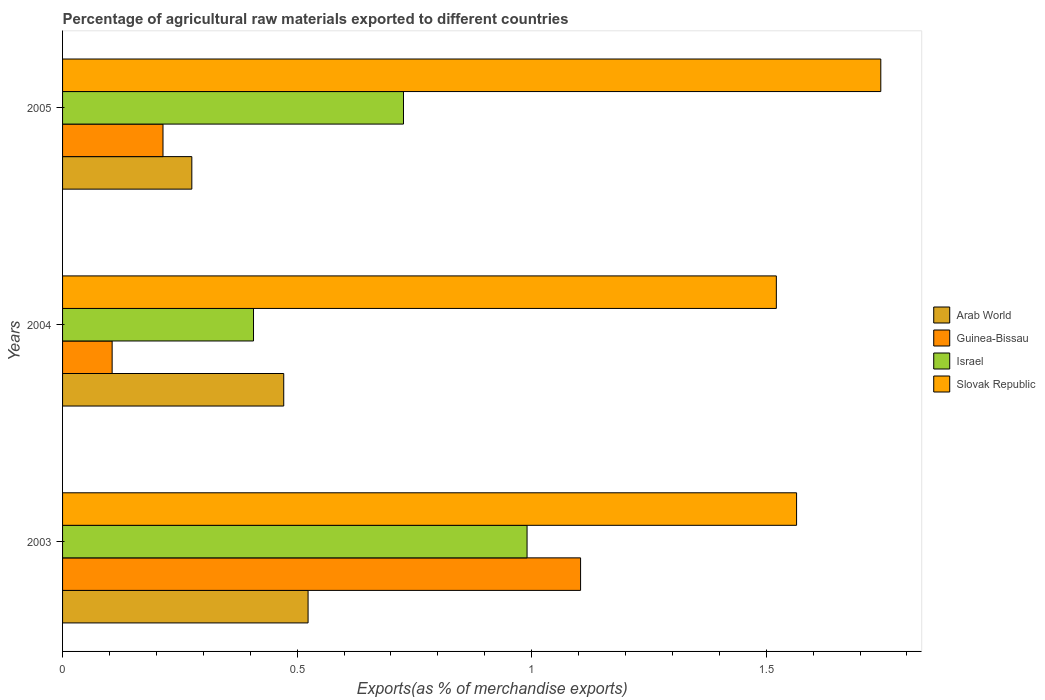How many different coloured bars are there?
Ensure brevity in your answer.  4. How many bars are there on the 1st tick from the top?
Keep it short and to the point. 4. In how many cases, is the number of bars for a given year not equal to the number of legend labels?
Your answer should be compact. 0. What is the percentage of exports to different countries in Guinea-Bissau in 2005?
Keep it short and to the point. 0.21. Across all years, what is the maximum percentage of exports to different countries in Israel?
Keep it short and to the point. 0.99. Across all years, what is the minimum percentage of exports to different countries in Guinea-Bissau?
Provide a succinct answer. 0.11. In which year was the percentage of exports to different countries in Israel minimum?
Your answer should be very brief. 2004. What is the total percentage of exports to different countries in Arab World in the graph?
Your answer should be very brief. 1.27. What is the difference between the percentage of exports to different countries in Slovak Republic in 2003 and that in 2005?
Ensure brevity in your answer.  -0.18. What is the difference between the percentage of exports to different countries in Arab World in 2004 and the percentage of exports to different countries in Guinea-Bissau in 2003?
Your answer should be very brief. -0.63. What is the average percentage of exports to different countries in Arab World per year?
Make the answer very short. 0.42. In the year 2005, what is the difference between the percentage of exports to different countries in Arab World and percentage of exports to different countries in Guinea-Bissau?
Make the answer very short. 0.06. In how many years, is the percentage of exports to different countries in Guinea-Bissau greater than 1.6 %?
Your answer should be compact. 0. What is the ratio of the percentage of exports to different countries in Arab World in 2004 to that in 2005?
Your answer should be very brief. 1.71. Is the percentage of exports to different countries in Slovak Republic in 2004 less than that in 2005?
Provide a short and direct response. Yes. Is the difference between the percentage of exports to different countries in Arab World in 2004 and 2005 greater than the difference between the percentage of exports to different countries in Guinea-Bissau in 2004 and 2005?
Offer a very short reply. Yes. What is the difference between the highest and the second highest percentage of exports to different countries in Israel?
Make the answer very short. 0.26. What is the difference between the highest and the lowest percentage of exports to different countries in Guinea-Bissau?
Ensure brevity in your answer.  1. Is the sum of the percentage of exports to different countries in Slovak Republic in 2003 and 2004 greater than the maximum percentage of exports to different countries in Guinea-Bissau across all years?
Make the answer very short. Yes. What does the 1st bar from the top in 2004 represents?
Keep it short and to the point. Slovak Republic. Is it the case that in every year, the sum of the percentage of exports to different countries in Slovak Republic and percentage of exports to different countries in Israel is greater than the percentage of exports to different countries in Arab World?
Your response must be concise. Yes. Are the values on the major ticks of X-axis written in scientific E-notation?
Offer a very short reply. No. Does the graph contain any zero values?
Give a very brief answer. No. Does the graph contain grids?
Your response must be concise. No. How are the legend labels stacked?
Your answer should be compact. Vertical. What is the title of the graph?
Offer a terse response. Percentage of agricultural raw materials exported to different countries. Does "Montenegro" appear as one of the legend labels in the graph?
Give a very brief answer. No. What is the label or title of the X-axis?
Make the answer very short. Exports(as % of merchandise exports). What is the label or title of the Y-axis?
Provide a succinct answer. Years. What is the Exports(as % of merchandise exports) of Arab World in 2003?
Offer a very short reply. 0.52. What is the Exports(as % of merchandise exports) in Guinea-Bissau in 2003?
Your response must be concise. 1.1. What is the Exports(as % of merchandise exports) of Israel in 2003?
Your answer should be very brief. 0.99. What is the Exports(as % of merchandise exports) of Slovak Republic in 2003?
Your answer should be very brief. 1.56. What is the Exports(as % of merchandise exports) in Arab World in 2004?
Your response must be concise. 0.47. What is the Exports(as % of merchandise exports) in Guinea-Bissau in 2004?
Your response must be concise. 0.11. What is the Exports(as % of merchandise exports) in Israel in 2004?
Offer a terse response. 0.41. What is the Exports(as % of merchandise exports) of Slovak Republic in 2004?
Offer a terse response. 1.52. What is the Exports(as % of merchandise exports) of Arab World in 2005?
Your response must be concise. 0.28. What is the Exports(as % of merchandise exports) of Guinea-Bissau in 2005?
Give a very brief answer. 0.21. What is the Exports(as % of merchandise exports) in Israel in 2005?
Offer a terse response. 0.73. What is the Exports(as % of merchandise exports) in Slovak Republic in 2005?
Your answer should be compact. 1.74. Across all years, what is the maximum Exports(as % of merchandise exports) in Arab World?
Provide a short and direct response. 0.52. Across all years, what is the maximum Exports(as % of merchandise exports) in Guinea-Bissau?
Ensure brevity in your answer.  1.1. Across all years, what is the maximum Exports(as % of merchandise exports) in Israel?
Offer a terse response. 0.99. Across all years, what is the maximum Exports(as % of merchandise exports) in Slovak Republic?
Offer a very short reply. 1.74. Across all years, what is the minimum Exports(as % of merchandise exports) of Arab World?
Ensure brevity in your answer.  0.28. Across all years, what is the minimum Exports(as % of merchandise exports) in Guinea-Bissau?
Provide a succinct answer. 0.11. Across all years, what is the minimum Exports(as % of merchandise exports) of Israel?
Offer a very short reply. 0.41. Across all years, what is the minimum Exports(as % of merchandise exports) in Slovak Republic?
Keep it short and to the point. 1.52. What is the total Exports(as % of merchandise exports) in Arab World in the graph?
Provide a succinct answer. 1.27. What is the total Exports(as % of merchandise exports) of Guinea-Bissau in the graph?
Offer a very short reply. 1.42. What is the total Exports(as % of merchandise exports) of Israel in the graph?
Your answer should be compact. 2.12. What is the total Exports(as % of merchandise exports) in Slovak Republic in the graph?
Keep it short and to the point. 4.83. What is the difference between the Exports(as % of merchandise exports) in Arab World in 2003 and that in 2004?
Make the answer very short. 0.05. What is the difference between the Exports(as % of merchandise exports) in Israel in 2003 and that in 2004?
Keep it short and to the point. 0.58. What is the difference between the Exports(as % of merchandise exports) in Slovak Republic in 2003 and that in 2004?
Your answer should be very brief. 0.04. What is the difference between the Exports(as % of merchandise exports) of Arab World in 2003 and that in 2005?
Your answer should be very brief. 0.25. What is the difference between the Exports(as % of merchandise exports) in Guinea-Bissau in 2003 and that in 2005?
Your response must be concise. 0.89. What is the difference between the Exports(as % of merchandise exports) of Israel in 2003 and that in 2005?
Offer a very short reply. 0.26. What is the difference between the Exports(as % of merchandise exports) of Slovak Republic in 2003 and that in 2005?
Make the answer very short. -0.18. What is the difference between the Exports(as % of merchandise exports) of Arab World in 2004 and that in 2005?
Provide a succinct answer. 0.2. What is the difference between the Exports(as % of merchandise exports) of Guinea-Bissau in 2004 and that in 2005?
Provide a succinct answer. -0.11. What is the difference between the Exports(as % of merchandise exports) in Israel in 2004 and that in 2005?
Make the answer very short. -0.32. What is the difference between the Exports(as % of merchandise exports) in Slovak Republic in 2004 and that in 2005?
Make the answer very short. -0.22. What is the difference between the Exports(as % of merchandise exports) of Arab World in 2003 and the Exports(as % of merchandise exports) of Guinea-Bissau in 2004?
Make the answer very short. 0.42. What is the difference between the Exports(as % of merchandise exports) in Arab World in 2003 and the Exports(as % of merchandise exports) in Israel in 2004?
Ensure brevity in your answer.  0.12. What is the difference between the Exports(as % of merchandise exports) in Arab World in 2003 and the Exports(as % of merchandise exports) in Slovak Republic in 2004?
Your response must be concise. -1. What is the difference between the Exports(as % of merchandise exports) of Guinea-Bissau in 2003 and the Exports(as % of merchandise exports) of Israel in 2004?
Provide a short and direct response. 0.7. What is the difference between the Exports(as % of merchandise exports) in Guinea-Bissau in 2003 and the Exports(as % of merchandise exports) in Slovak Republic in 2004?
Make the answer very short. -0.42. What is the difference between the Exports(as % of merchandise exports) of Israel in 2003 and the Exports(as % of merchandise exports) of Slovak Republic in 2004?
Keep it short and to the point. -0.53. What is the difference between the Exports(as % of merchandise exports) in Arab World in 2003 and the Exports(as % of merchandise exports) in Guinea-Bissau in 2005?
Your response must be concise. 0.31. What is the difference between the Exports(as % of merchandise exports) of Arab World in 2003 and the Exports(as % of merchandise exports) of Israel in 2005?
Offer a very short reply. -0.2. What is the difference between the Exports(as % of merchandise exports) of Arab World in 2003 and the Exports(as % of merchandise exports) of Slovak Republic in 2005?
Ensure brevity in your answer.  -1.22. What is the difference between the Exports(as % of merchandise exports) in Guinea-Bissau in 2003 and the Exports(as % of merchandise exports) in Israel in 2005?
Keep it short and to the point. 0.38. What is the difference between the Exports(as % of merchandise exports) of Guinea-Bissau in 2003 and the Exports(as % of merchandise exports) of Slovak Republic in 2005?
Offer a terse response. -0.64. What is the difference between the Exports(as % of merchandise exports) of Israel in 2003 and the Exports(as % of merchandise exports) of Slovak Republic in 2005?
Make the answer very short. -0.75. What is the difference between the Exports(as % of merchandise exports) in Arab World in 2004 and the Exports(as % of merchandise exports) in Guinea-Bissau in 2005?
Give a very brief answer. 0.26. What is the difference between the Exports(as % of merchandise exports) of Arab World in 2004 and the Exports(as % of merchandise exports) of Israel in 2005?
Ensure brevity in your answer.  -0.26. What is the difference between the Exports(as % of merchandise exports) in Arab World in 2004 and the Exports(as % of merchandise exports) in Slovak Republic in 2005?
Your response must be concise. -1.27. What is the difference between the Exports(as % of merchandise exports) in Guinea-Bissau in 2004 and the Exports(as % of merchandise exports) in Israel in 2005?
Provide a short and direct response. -0.62. What is the difference between the Exports(as % of merchandise exports) in Guinea-Bissau in 2004 and the Exports(as % of merchandise exports) in Slovak Republic in 2005?
Your response must be concise. -1.64. What is the difference between the Exports(as % of merchandise exports) of Israel in 2004 and the Exports(as % of merchandise exports) of Slovak Republic in 2005?
Provide a short and direct response. -1.34. What is the average Exports(as % of merchandise exports) in Arab World per year?
Your response must be concise. 0.42. What is the average Exports(as % of merchandise exports) of Guinea-Bissau per year?
Keep it short and to the point. 0.47. What is the average Exports(as % of merchandise exports) of Israel per year?
Your answer should be very brief. 0.71. What is the average Exports(as % of merchandise exports) of Slovak Republic per year?
Offer a very short reply. 1.61. In the year 2003, what is the difference between the Exports(as % of merchandise exports) in Arab World and Exports(as % of merchandise exports) in Guinea-Bissau?
Ensure brevity in your answer.  -0.58. In the year 2003, what is the difference between the Exports(as % of merchandise exports) of Arab World and Exports(as % of merchandise exports) of Israel?
Ensure brevity in your answer.  -0.47. In the year 2003, what is the difference between the Exports(as % of merchandise exports) in Arab World and Exports(as % of merchandise exports) in Slovak Republic?
Provide a short and direct response. -1.04. In the year 2003, what is the difference between the Exports(as % of merchandise exports) in Guinea-Bissau and Exports(as % of merchandise exports) in Israel?
Your response must be concise. 0.11. In the year 2003, what is the difference between the Exports(as % of merchandise exports) of Guinea-Bissau and Exports(as % of merchandise exports) of Slovak Republic?
Make the answer very short. -0.46. In the year 2003, what is the difference between the Exports(as % of merchandise exports) in Israel and Exports(as % of merchandise exports) in Slovak Republic?
Keep it short and to the point. -0.57. In the year 2004, what is the difference between the Exports(as % of merchandise exports) in Arab World and Exports(as % of merchandise exports) in Guinea-Bissau?
Give a very brief answer. 0.37. In the year 2004, what is the difference between the Exports(as % of merchandise exports) in Arab World and Exports(as % of merchandise exports) in Israel?
Give a very brief answer. 0.06. In the year 2004, what is the difference between the Exports(as % of merchandise exports) in Arab World and Exports(as % of merchandise exports) in Slovak Republic?
Make the answer very short. -1.05. In the year 2004, what is the difference between the Exports(as % of merchandise exports) of Guinea-Bissau and Exports(as % of merchandise exports) of Israel?
Provide a short and direct response. -0.3. In the year 2004, what is the difference between the Exports(as % of merchandise exports) of Guinea-Bissau and Exports(as % of merchandise exports) of Slovak Republic?
Your answer should be compact. -1.42. In the year 2004, what is the difference between the Exports(as % of merchandise exports) in Israel and Exports(as % of merchandise exports) in Slovak Republic?
Offer a terse response. -1.11. In the year 2005, what is the difference between the Exports(as % of merchandise exports) in Arab World and Exports(as % of merchandise exports) in Guinea-Bissau?
Your answer should be very brief. 0.06. In the year 2005, what is the difference between the Exports(as % of merchandise exports) of Arab World and Exports(as % of merchandise exports) of Israel?
Offer a very short reply. -0.45. In the year 2005, what is the difference between the Exports(as % of merchandise exports) of Arab World and Exports(as % of merchandise exports) of Slovak Republic?
Give a very brief answer. -1.47. In the year 2005, what is the difference between the Exports(as % of merchandise exports) of Guinea-Bissau and Exports(as % of merchandise exports) of Israel?
Your response must be concise. -0.51. In the year 2005, what is the difference between the Exports(as % of merchandise exports) of Guinea-Bissau and Exports(as % of merchandise exports) of Slovak Republic?
Ensure brevity in your answer.  -1.53. In the year 2005, what is the difference between the Exports(as % of merchandise exports) of Israel and Exports(as % of merchandise exports) of Slovak Republic?
Offer a terse response. -1.02. What is the ratio of the Exports(as % of merchandise exports) of Arab World in 2003 to that in 2004?
Offer a terse response. 1.11. What is the ratio of the Exports(as % of merchandise exports) of Guinea-Bissau in 2003 to that in 2004?
Offer a terse response. 10.45. What is the ratio of the Exports(as % of merchandise exports) in Israel in 2003 to that in 2004?
Provide a short and direct response. 2.43. What is the ratio of the Exports(as % of merchandise exports) in Slovak Republic in 2003 to that in 2004?
Offer a very short reply. 1.03. What is the ratio of the Exports(as % of merchandise exports) of Arab World in 2003 to that in 2005?
Offer a terse response. 1.9. What is the ratio of the Exports(as % of merchandise exports) of Guinea-Bissau in 2003 to that in 2005?
Provide a succinct answer. 5.16. What is the ratio of the Exports(as % of merchandise exports) of Israel in 2003 to that in 2005?
Offer a very short reply. 1.36. What is the ratio of the Exports(as % of merchandise exports) in Slovak Republic in 2003 to that in 2005?
Give a very brief answer. 0.9. What is the ratio of the Exports(as % of merchandise exports) in Arab World in 2004 to that in 2005?
Ensure brevity in your answer.  1.71. What is the ratio of the Exports(as % of merchandise exports) of Guinea-Bissau in 2004 to that in 2005?
Your response must be concise. 0.49. What is the ratio of the Exports(as % of merchandise exports) in Israel in 2004 to that in 2005?
Give a very brief answer. 0.56. What is the ratio of the Exports(as % of merchandise exports) in Slovak Republic in 2004 to that in 2005?
Provide a short and direct response. 0.87. What is the difference between the highest and the second highest Exports(as % of merchandise exports) of Arab World?
Keep it short and to the point. 0.05. What is the difference between the highest and the second highest Exports(as % of merchandise exports) of Guinea-Bissau?
Provide a succinct answer. 0.89. What is the difference between the highest and the second highest Exports(as % of merchandise exports) in Israel?
Provide a short and direct response. 0.26. What is the difference between the highest and the second highest Exports(as % of merchandise exports) of Slovak Republic?
Give a very brief answer. 0.18. What is the difference between the highest and the lowest Exports(as % of merchandise exports) in Arab World?
Offer a very short reply. 0.25. What is the difference between the highest and the lowest Exports(as % of merchandise exports) of Israel?
Offer a very short reply. 0.58. What is the difference between the highest and the lowest Exports(as % of merchandise exports) of Slovak Republic?
Provide a succinct answer. 0.22. 